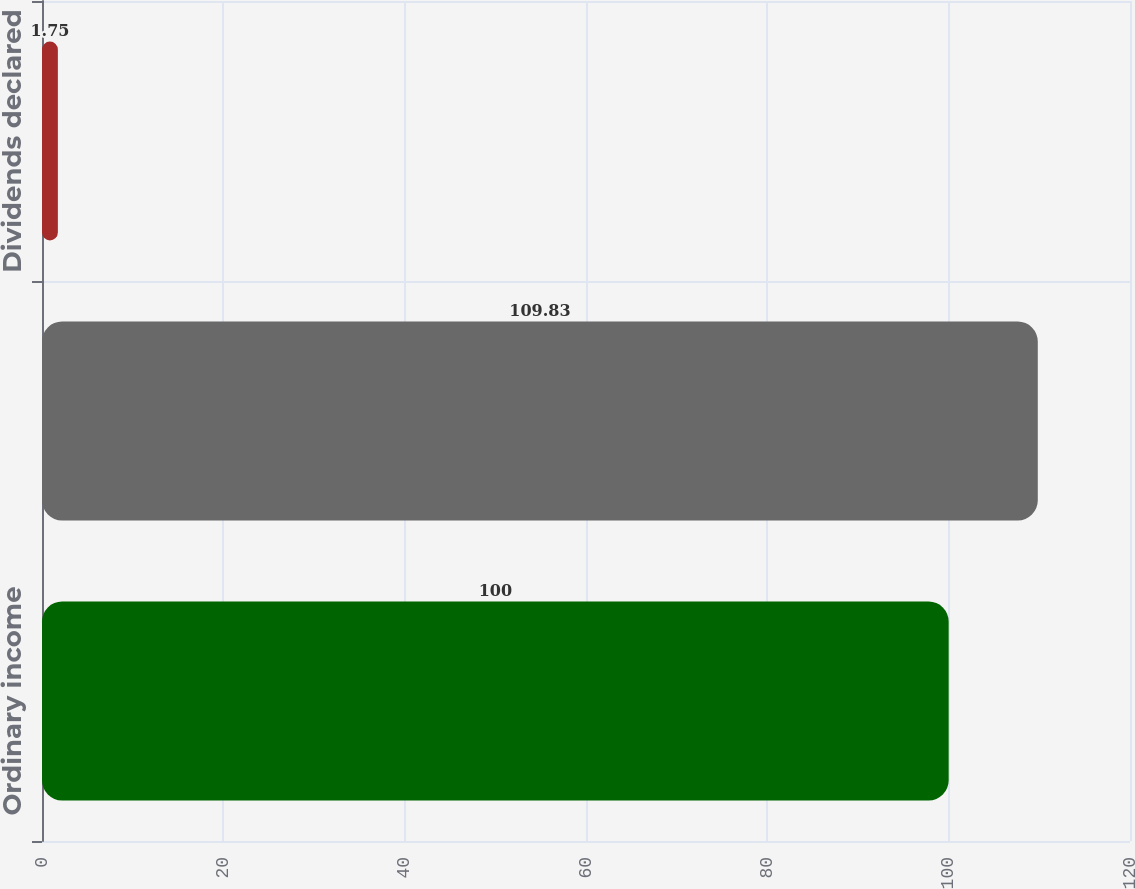<chart> <loc_0><loc_0><loc_500><loc_500><bar_chart><fcel>Ordinary income<fcel>Total<fcel>Dividends declared<nl><fcel>100<fcel>109.83<fcel>1.75<nl></chart> 